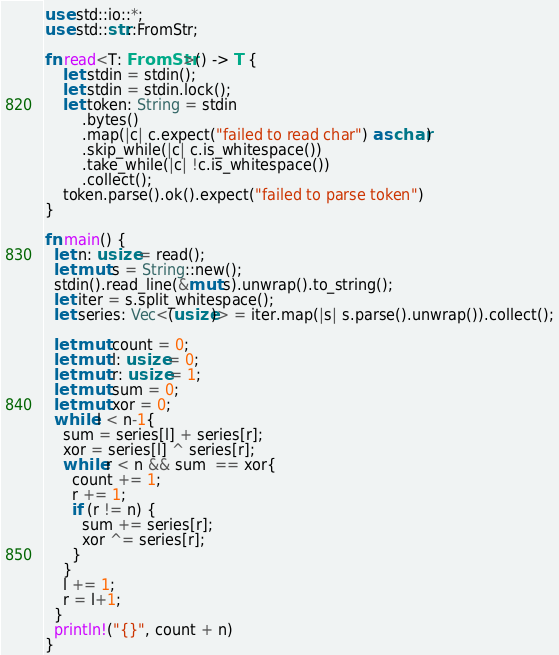<code> <loc_0><loc_0><loc_500><loc_500><_Rust_>use std::io::*;
use std::str::FromStr;

fn read<T: FromStr>() -> T {
    let stdin = stdin();
    let stdin = stdin.lock();
    let token: String = stdin
        .bytes()
        .map(|c| c.expect("failed to read char") as char) 
        .skip_while(|c| c.is_whitespace())
        .take_while(|c| !c.is_whitespace())
        .collect();
    token.parse().ok().expect("failed to parse token")
}

fn main() {
  let n: usize = read();
  let mut s = String::new();
  stdin().read_line(&mut s).unwrap().to_string();
  let iter = s.split_whitespace();
  let series: Vec<(usize)> = iter.map(|s| s.parse().unwrap()).collect();
  
  let mut count = 0;
  let mut l: usize = 0;
  let mut r: usize = 1;
  let mut sum = 0;
  let mut xor = 0;
  while l < n-1{
    sum = series[l] + series[r];
    xor = series[l] ^ series[r];
    while r < n && sum  == xor{
      count += 1;
      r += 1;
      if (r != n) {
        sum += series[r];
        xor ^= series[r];
      }
    }
    l += 1;
    r = l+1;
  }
  println!("{}", count + n)
}
</code> 